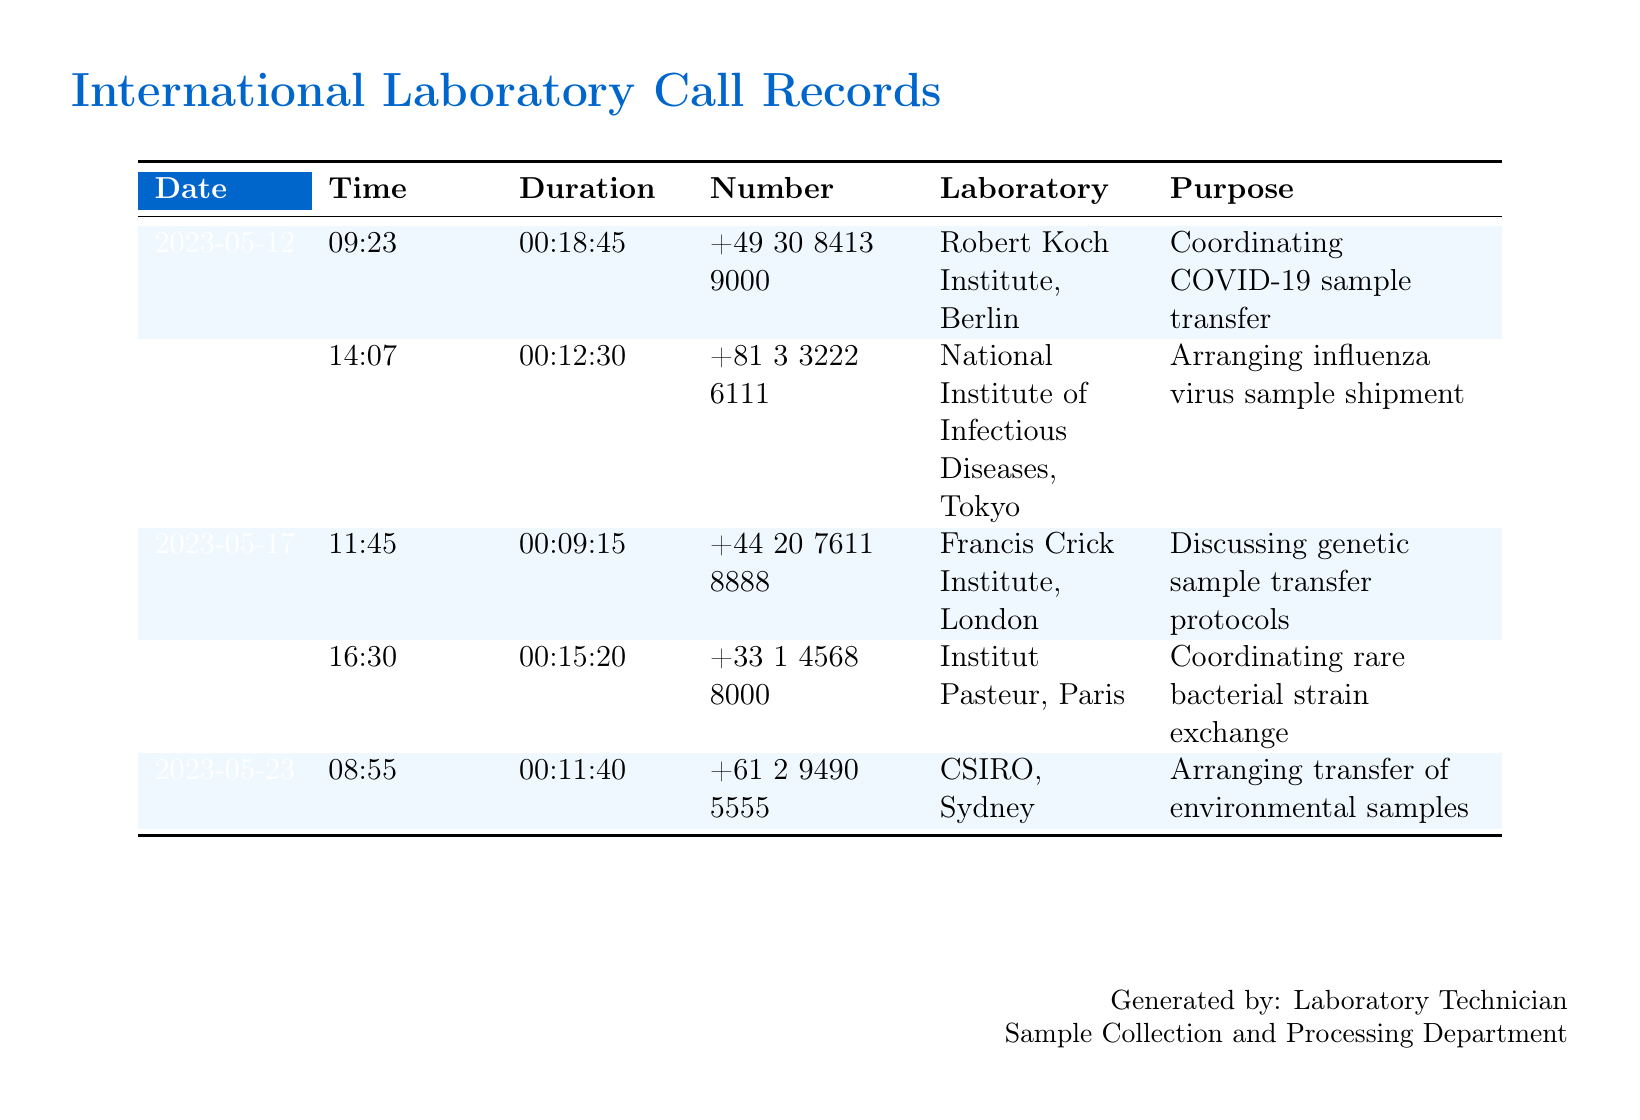What is the date of the call to the Robert Koch Institute? The date of the call is specifically noted under the Date column for that entry.
Answer: 2023-05-12 What is the duration of the call to the National Institute of Infectious Diseases? The duration is recorded in the Duration column corresponding to the specified laboratory.
Answer: 00:12:30 How many calls were made to European laboratories? This requires counting the entries where the laboratory is located in Europe; the entries for Berlin, London, and Paris provide that information.
Answer: 3 What is the purpose of the call made on May 20th? The purpose of that call is detailed under the Purpose column for that specific date.
Answer: Coordinating rare bacterial strain exchange What is the telephone number for CSIRO in Sydney? The document lists the telephone number in the Number column corresponding to CSIRO.
Answer: +61 2 9490 5555 